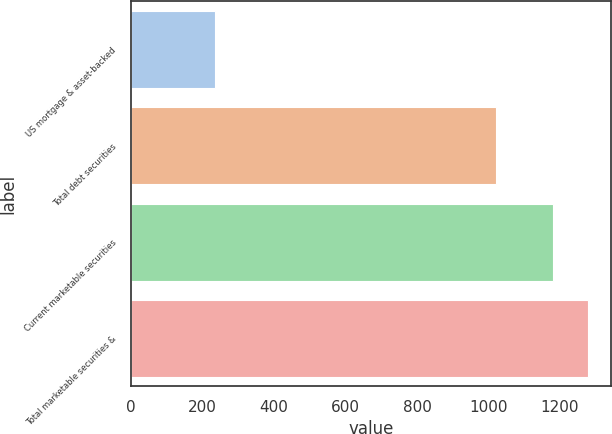Convert chart. <chart><loc_0><loc_0><loc_500><loc_500><bar_chart><fcel>US mortgage & asset-backed<fcel>Total debt securities<fcel>Current marketable securities<fcel>Total marketable securities &<nl><fcel>234<fcel>1021<fcel>1181<fcel>1278.1<nl></chart> 